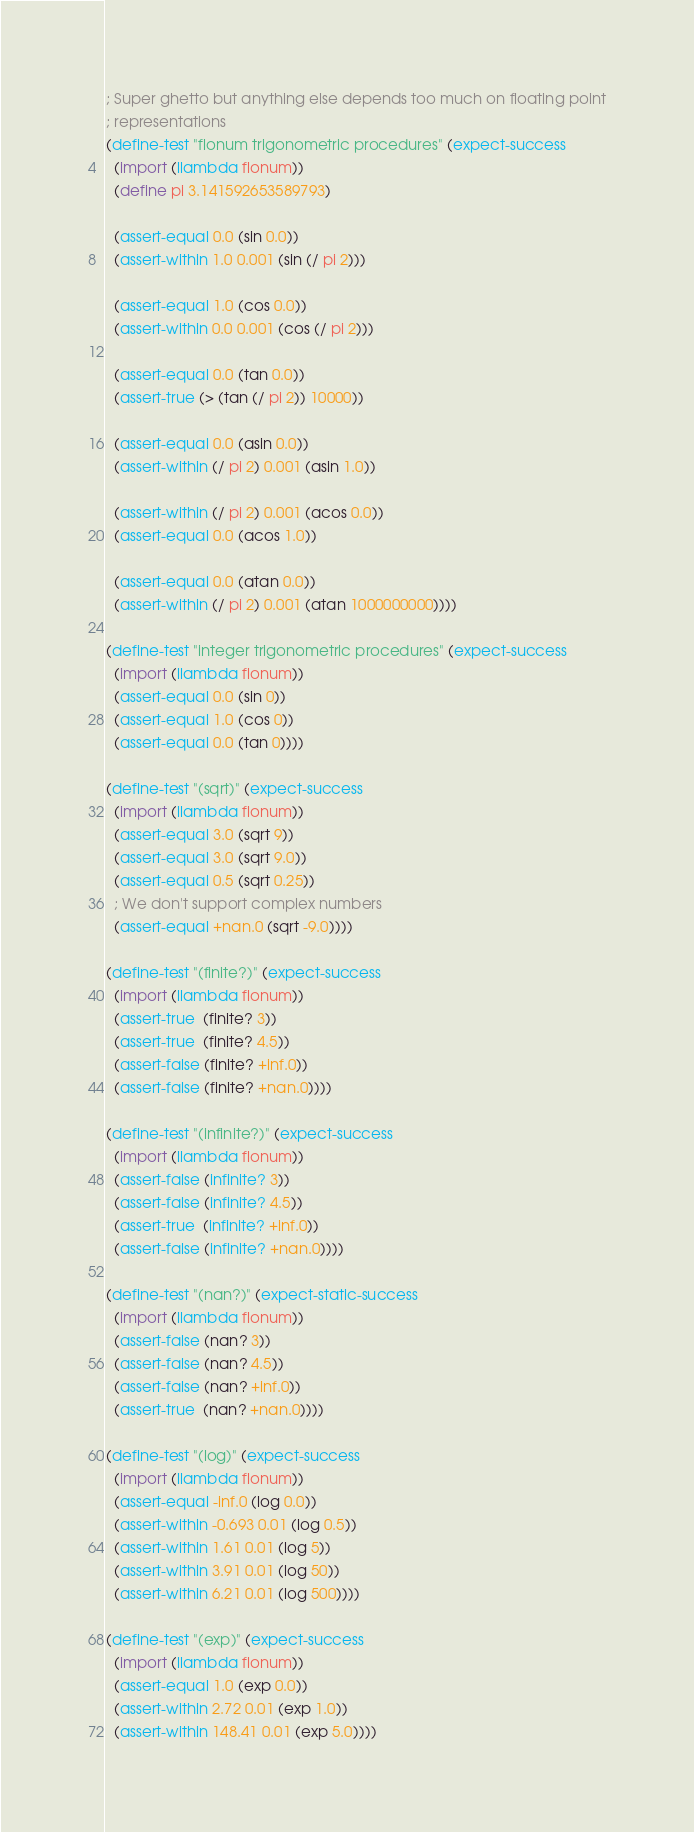<code> <loc_0><loc_0><loc_500><loc_500><_Scheme_>; Super ghetto but anything else depends too much on floating point
; representations
(define-test "flonum trigonometric procedures" (expect-success
  (import (llambda flonum))
  (define pi 3.141592653589793)

  (assert-equal 0.0 (sin 0.0))
  (assert-within 1.0 0.001 (sin (/ pi 2)))

  (assert-equal 1.0 (cos 0.0))
  (assert-within 0.0 0.001 (cos (/ pi 2)))

  (assert-equal 0.0 (tan 0.0))
  (assert-true (> (tan (/ pi 2)) 10000))

  (assert-equal 0.0 (asin 0.0))
  (assert-within (/ pi 2) 0.001 (asin 1.0))

  (assert-within (/ pi 2) 0.001 (acos 0.0))
  (assert-equal 0.0 (acos 1.0))

  (assert-equal 0.0 (atan 0.0))
  (assert-within (/ pi 2) 0.001 (atan 1000000000))))

(define-test "integer trigonometric procedures" (expect-success
  (import (llambda flonum))
  (assert-equal 0.0 (sin 0))
  (assert-equal 1.0 (cos 0))
  (assert-equal 0.0 (tan 0))))

(define-test "(sqrt)" (expect-success
  (import (llambda flonum))
  (assert-equal 3.0 (sqrt 9))
  (assert-equal 3.0 (sqrt 9.0))
  (assert-equal 0.5 (sqrt 0.25))
  ; We don't support complex numbers
  (assert-equal +nan.0 (sqrt -9.0))))

(define-test "(finite?)" (expect-success
  (import (llambda flonum))
  (assert-true  (finite? 3))
  (assert-true  (finite? 4.5))
  (assert-false (finite? +inf.0))
  (assert-false (finite? +nan.0))))

(define-test "(infinite?)" (expect-success
  (import (llambda flonum))
  (assert-false (infinite? 3))
  (assert-false (infinite? 4.5))
  (assert-true  (infinite? +inf.0))
  (assert-false (infinite? +nan.0))))

(define-test "(nan?)" (expect-static-success
  (import (llambda flonum))
  (assert-false (nan? 3))
  (assert-false (nan? 4.5))
  (assert-false (nan? +inf.0))
  (assert-true  (nan? +nan.0))))

(define-test "(log)" (expect-success
  (import (llambda flonum))
  (assert-equal -inf.0 (log 0.0))
  (assert-within -0.693 0.01 (log 0.5))
  (assert-within 1.61 0.01 (log 5))
  (assert-within 3.91 0.01 (log 50))
  (assert-within 6.21 0.01 (log 500))))

(define-test "(exp)" (expect-success
  (import (llambda flonum))
  (assert-equal 1.0 (exp 0.0))
  (assert-within 2.72 0.01 (exp 1.0))
  (assert-within 148.41 0.01 (exp 5.0))))
</code> 